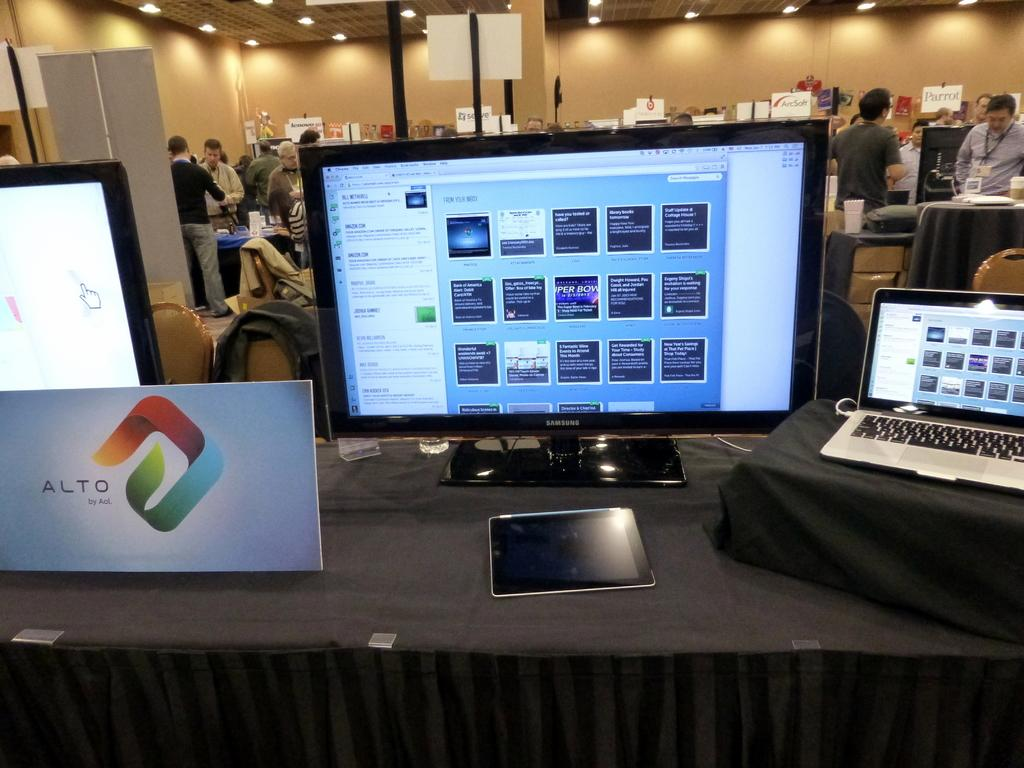<image>
Offer a succinct explanation of the picture presented. An Alto by AOL computer monitor is turned on with a laptop by its side. 